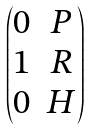Convert formula to latex. <formula><loc_0><loc_0><loc_500><loc_500>\begin{pmatrix} 0 & P \\ 1 & R \\ 0 & H \end{pmatrix}</formula> 